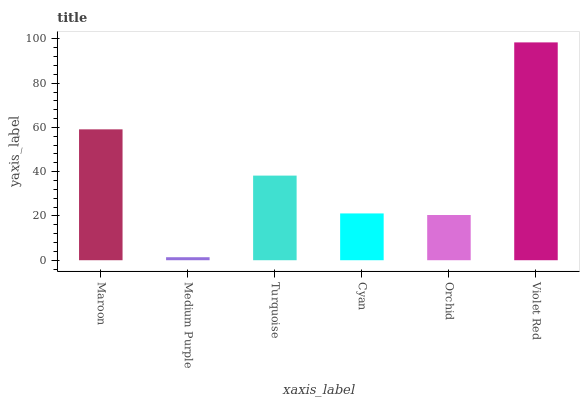Is Medium Purple the minimum?
Answer yes or no. Yes. Is Violet Red the maximum?
Answer yes or no. Yes. Is Turquoise the minimum?
Answer yes or no. No. Is Turquoise the maximum?
Answer yes or no. No. Is Turquoise greater than Medium Purple?
Answer yes or no. Yes. Is Medium Purple less than Turquoise?
Answer yes or no. Yes. Is Medium Purple greater than Turquoise?
Answer yes or no. No. Is Turquoise less than Medium Purple?
Answer yes or no. No. Is Turquoise the high median?
Answer yes or no. Yes. Is Cyan the low median?
Answer yes or no. Yes. Is Medium Purple the high median?
Answer yes or no. No. Is Medium Purple the low median?
Answer yes or no. No. 